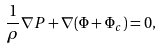Convert formula to latex. <formula><loc_0><loc_0><loc_500><loc_500>\frac { 1 } { \rho } \nabla P + \nabla ( \Phi + \Phi _ { c } ) = 0 ,</formula> 